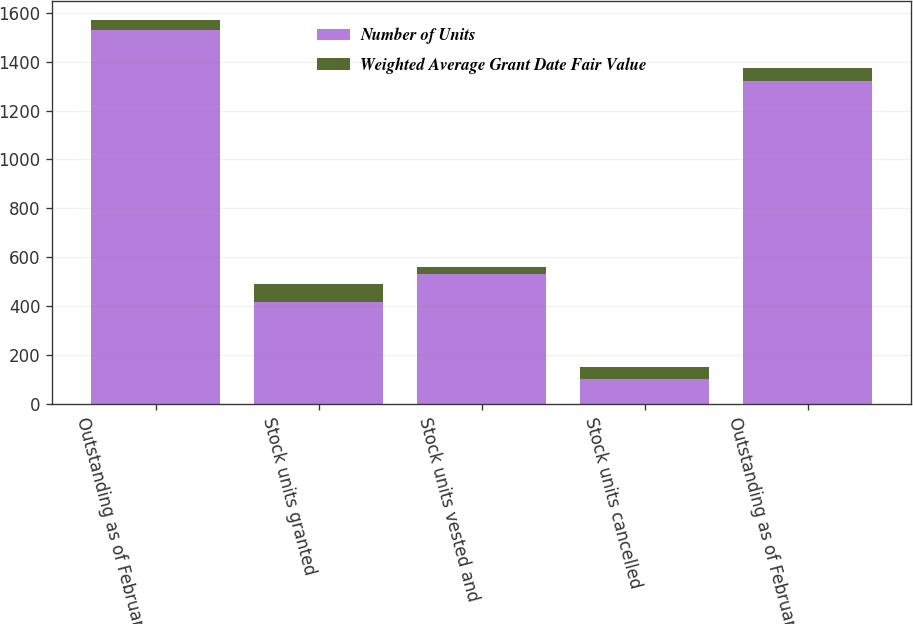Convert chart. <chart><loc_0><loc_0><loc_500><loc_500><stacked_bar_chart><ecel><fcel>Outstanding as of February 28<fcel>Stock units granted<fcel>Stock units vested and<fcel>Stock units cancelled<fcel>Outstanding as of February 29<nl><fcel>Number of Units<fcel>1530<fcel>418<fcel>529<fcel>99<fcel>1320<nl><fcel>Weighted Average Grant Date Fair Value<fcel>39.81<fcel>73.76<fcel>32.35<fcel>51.29<fcel>52.7<nl></chart> 